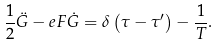Convert formula to latex. <formula><loc_0><loc_0><loc_500><loc_500>\frac { 1 } { 2 } \ddot { G } - e F \dot { G } = \delta \left ( \tau - \tau ^ { \prime } \right ) - \frac { 1 } { T } .</formula> 